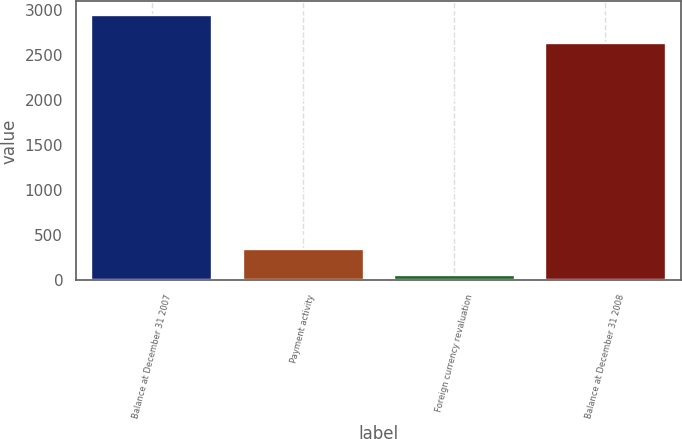<chart> <loc_0><loc_0><loc_500><loc_500><bar_chart><fcel>Balance at December 31 2007<fcel>Payment activity<fcel>Foreign currency revaluation<fcel>Balance at December 31 2008<nl><fcel>2942<fcel>350.9<fcel>63<fcel>2629<nl></chart> 